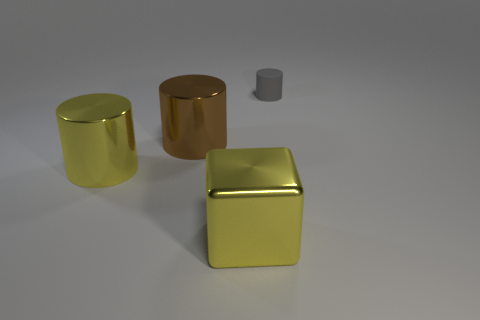How would you describe the lighting conditions and shadows cast by the objects in the image? The lighting in the image seems to be diffused, coming from above and slightly to the right, as indicated by the soft shadows under the objects. The shadows are subtle and elongate mostly towards the left, suggesting the light source is not extremely intense but is effectively illuminating the scene. 